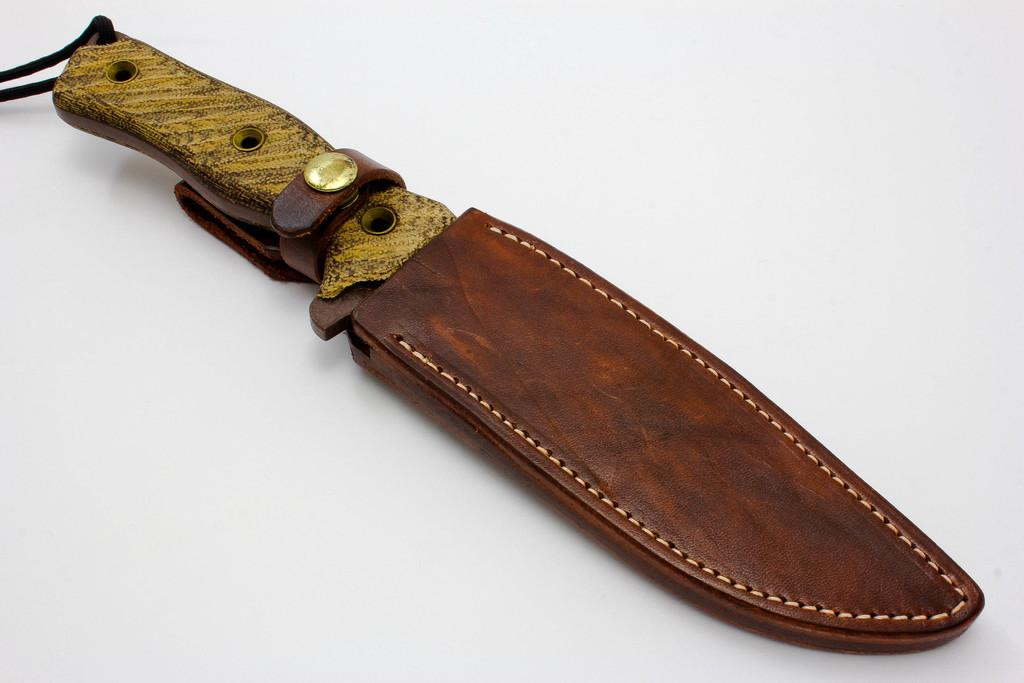What object is present on the table in the image? There is a knife on the table in the image. What type of discussion is taking place between the carpenter and the knife in the image? There is no carpenter or discussion present in the image; it only features a knife on a table. 